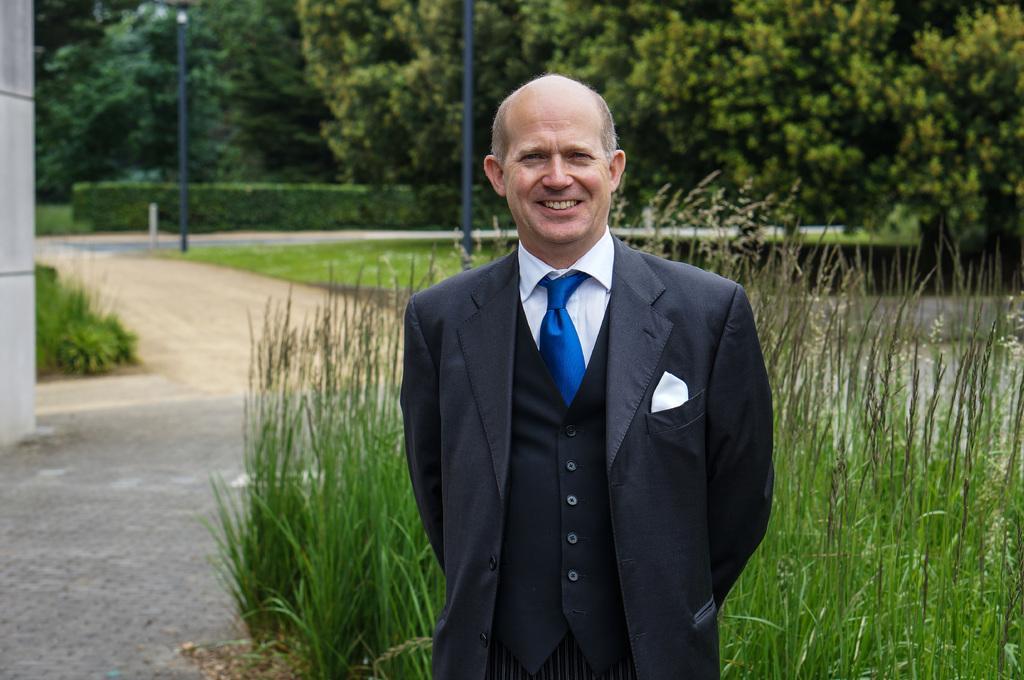In one or two sentences, can you explain what this image depicts? In this image we can see a man standing and smiling. In the background there are trees, bushes, poles, roads and grass. 